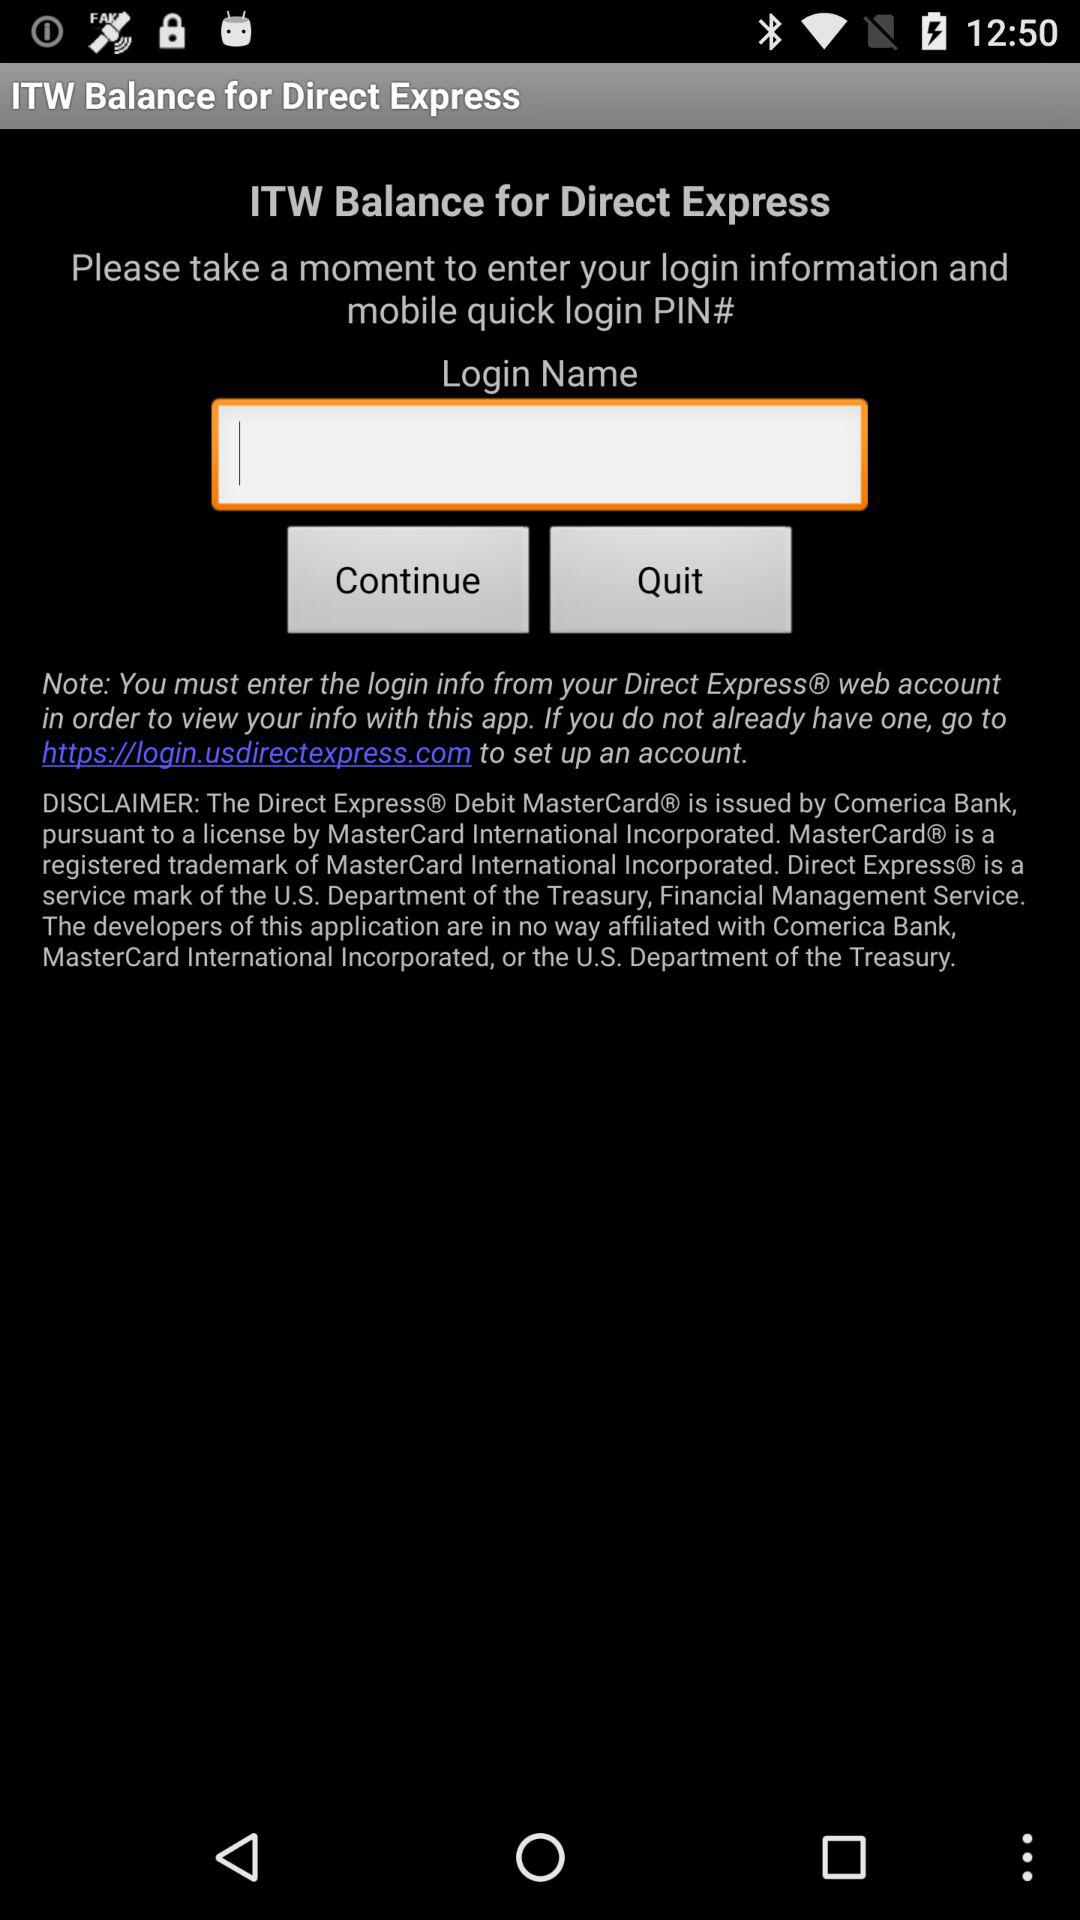What is the application name? The application name is "ITW Balance for Direct Express". 